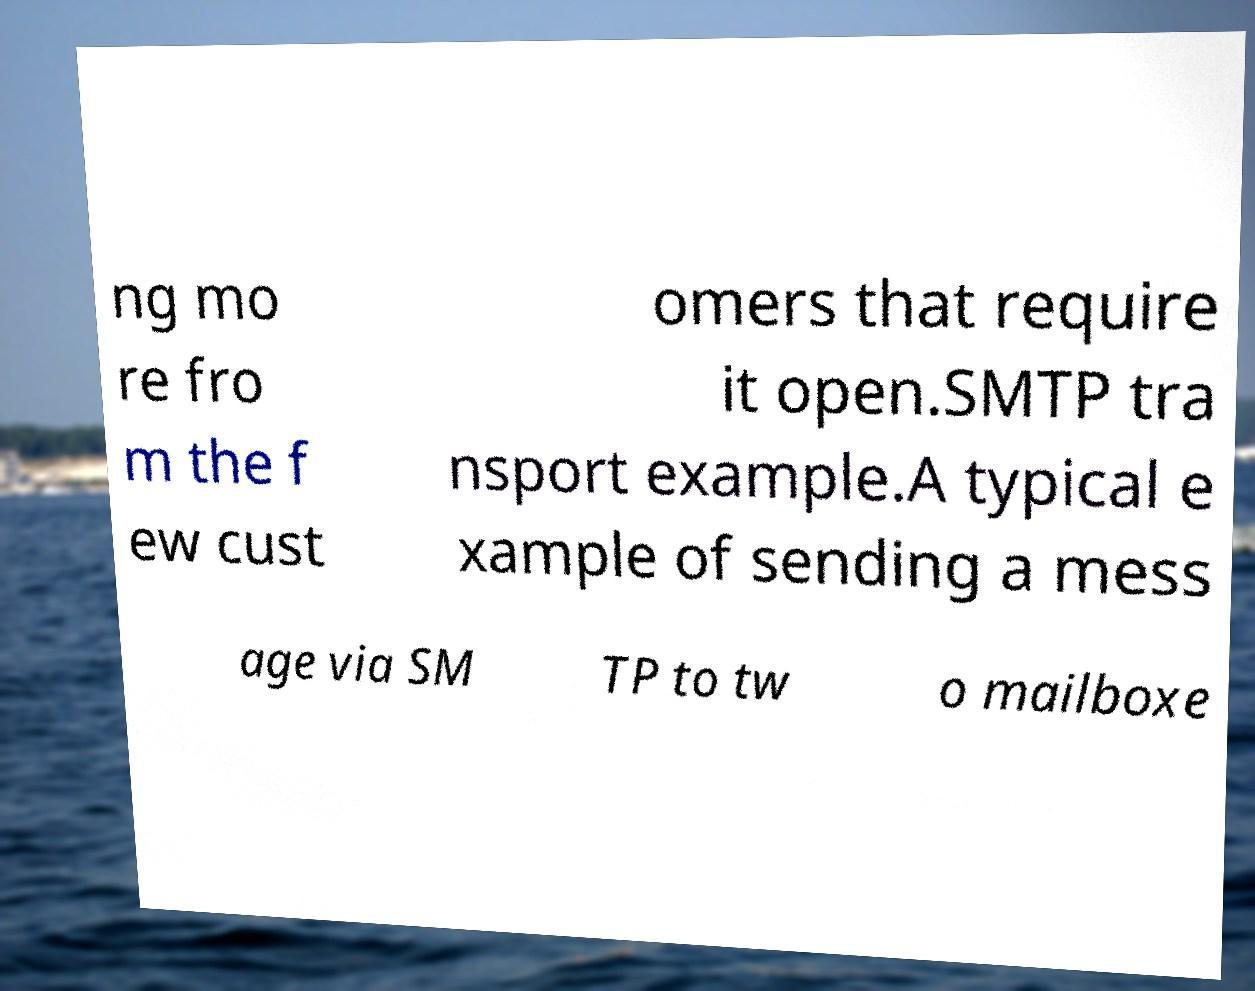Could you assist in decoding the text presented in this image and type it out clearly? ng mo re fro m the f ew cust omers that require it open.SMTP tra nsport example.A typical e xample of sending a mess age via SM TP to tw o mailboxe 